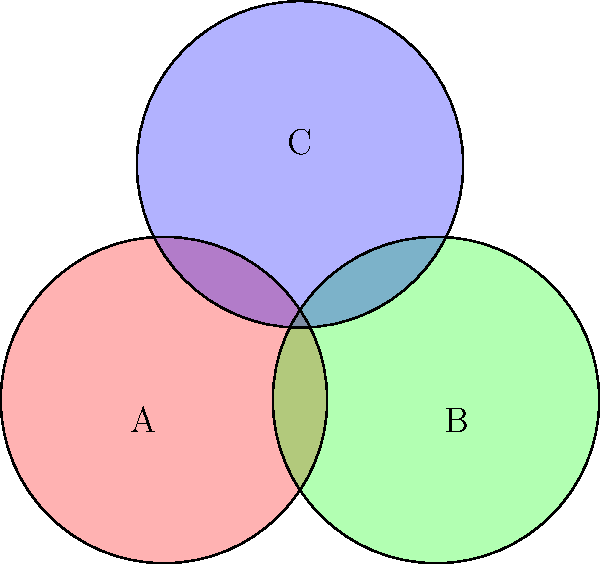In a metadata management system, three overlapping categories (A, B, and C) are represented by a Venn diagram. How many distinct regions, including the outer area, are created by the intersection of these three categories? To determine the number of distinct regions in this Venn diagram, we need to count systematically:

1. Start with the outer region (not in any circle): 1 region

2. Regions within single circles:
   - Only in A: 1 region
   - Only in B: 1 region
   - Only in C: 1 region

3. Regions within intersections of two circles:
   - A ∩ B (but not C): 1 region
   - A ∩ C (but not B): 1 region
   - B ∩ C (but not A): 1 region

4. Region within intersection of all three circles:
   - A ∩ B ∩ C: 1 region

To get the total, we sum all these regions:
$$ 1 + 3 + 3 + 1 = 8 $$

Therefore, there are 8 distinct regions in total, including the outer area not covered by any circle.
Answer: 8 regions 